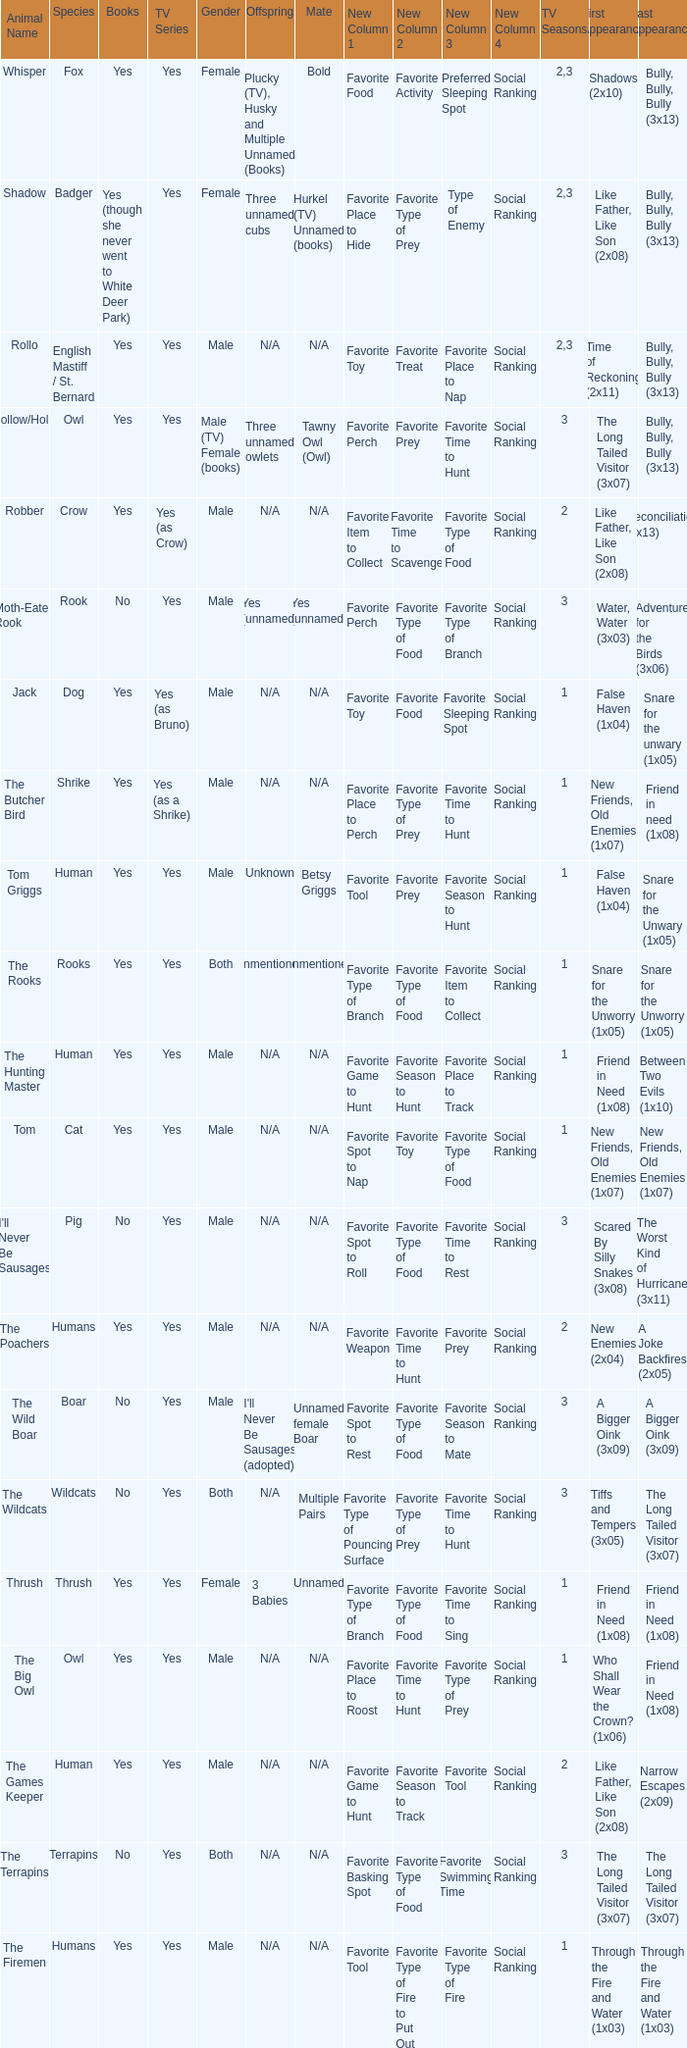What is the mate for Last Appearance of bully, bully, bully (3x13) for the animal named hollow/holly later than season 1? Tawny Owl (Owl). 